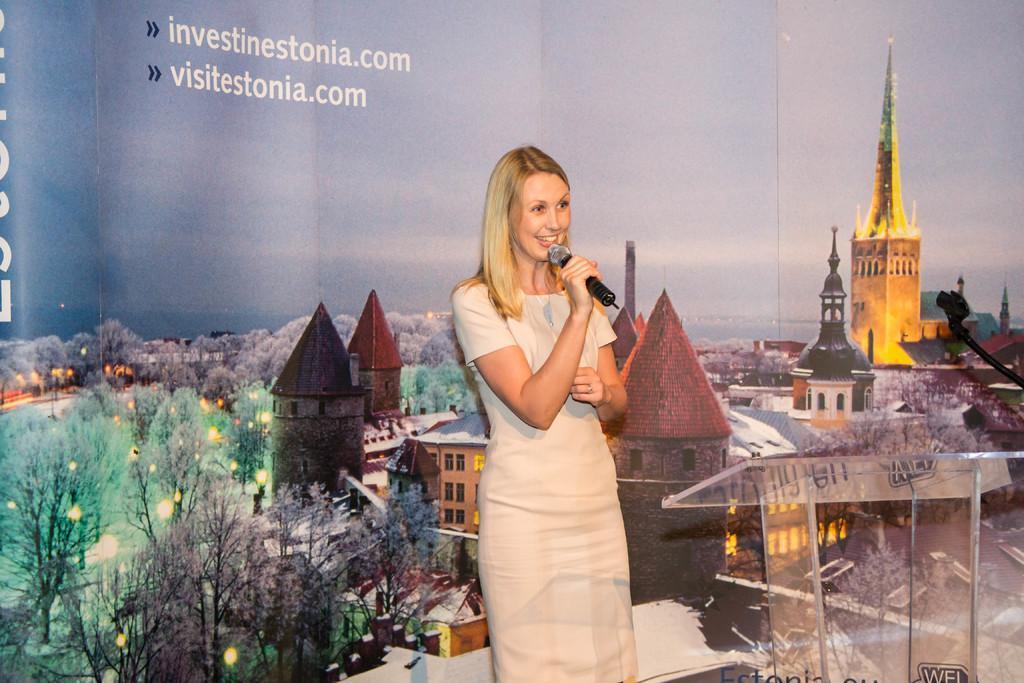Can you describe this image briefly? In this image I can see a woman standing and holding a microphone. There is a glass table on the right. There is a banner at the back. 